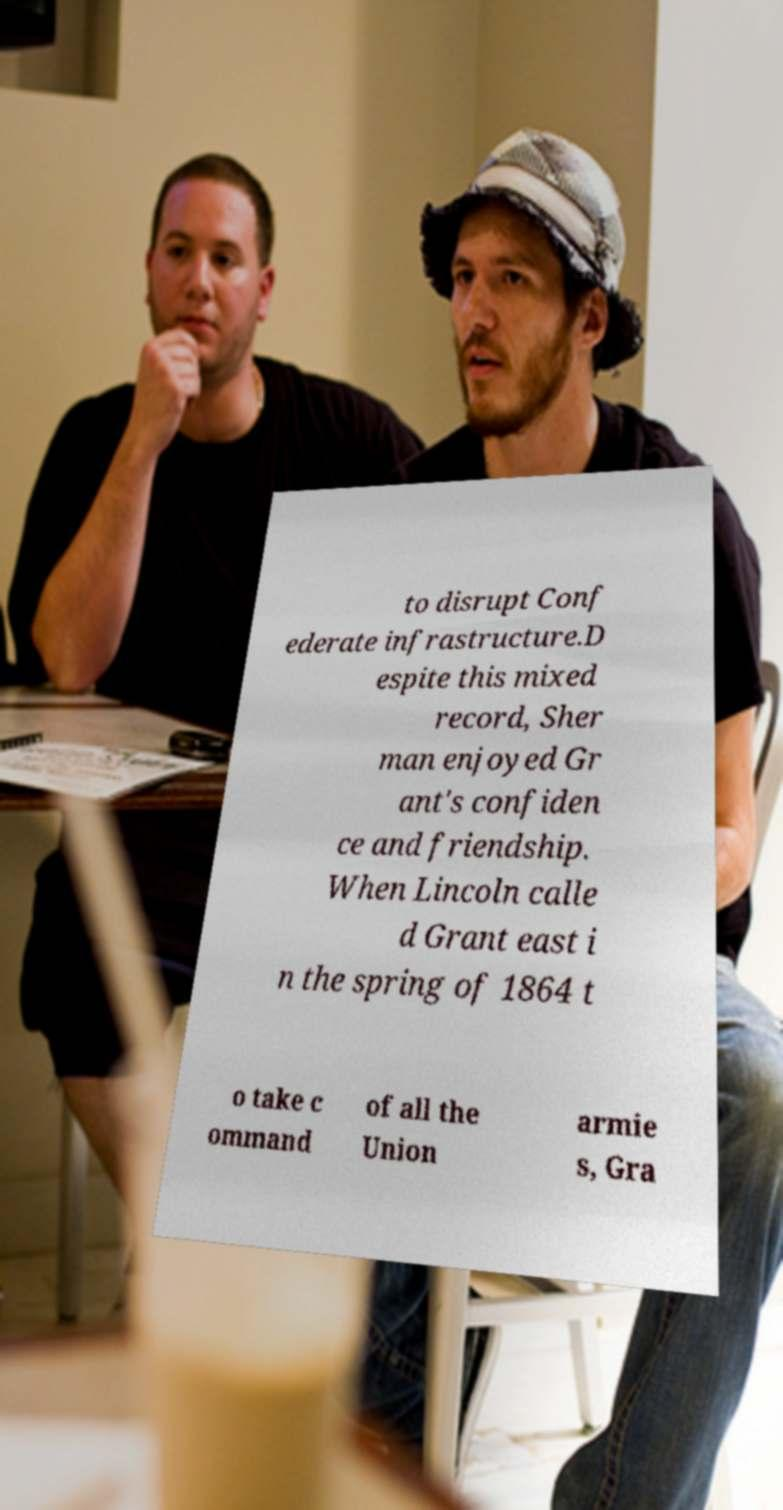Can you accurately transcribe the text from the provided image for me? to disrupt Conf ederate infrastructure.D espite this mixed record, Sher man enjoyed Gr ant's confiden ce and friendship. When Lincoln calle d Grant east i n the spring of 1864 t o take c ommand of all the Union armie s, Gra 